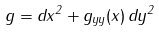Convert formula to latex. <formula><loc_0><loc_0><loc_500><loc_500>g = d x ^ { 2 } + g _ { y y } ( x ) \, d y ^ { 2 }</formula> 